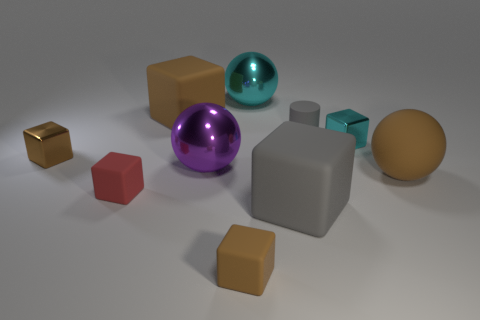Subtract all cyan shiny balls. How many balls are left? 2 Subtract all purple spheres. How many spheres are left? 2 Subtract 2 blocks. How many blocks are left? 4 Add 2 gray cylinders. How many gray cylinders are left? 3 Add 3 red things. How many red things exist? 4 Subtract 1 red blocks. How many objects are left? 9 Subtract all spheres. How many objects are left? 7 Subtract all gray cubes. Subtract all green cylinders. How many cubes are left? 5 Subtract all yellow spheres. How many yellow cylinders are left? 0 Subtract all large brown spheres. Subtract all metal cubes. How many objects are left? 7 